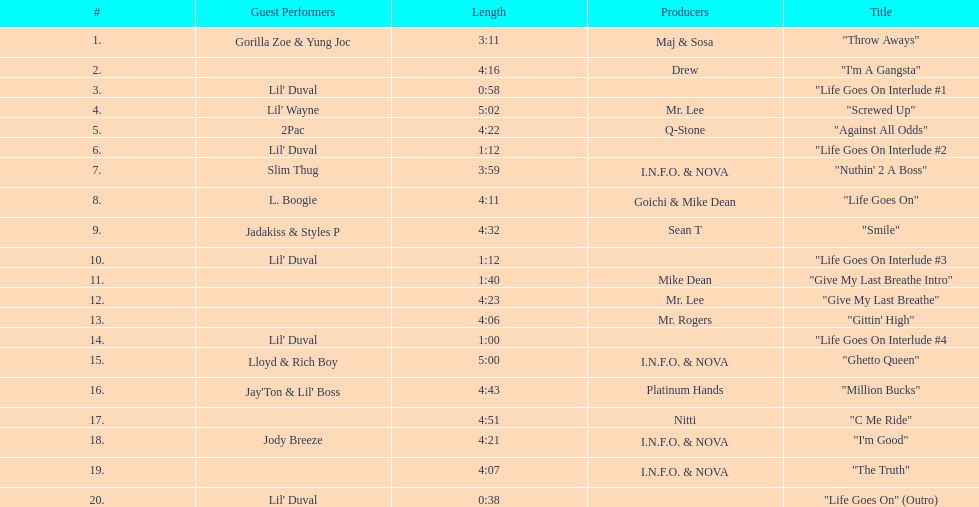How many tracks on trae's album "life goes on"? 20. 